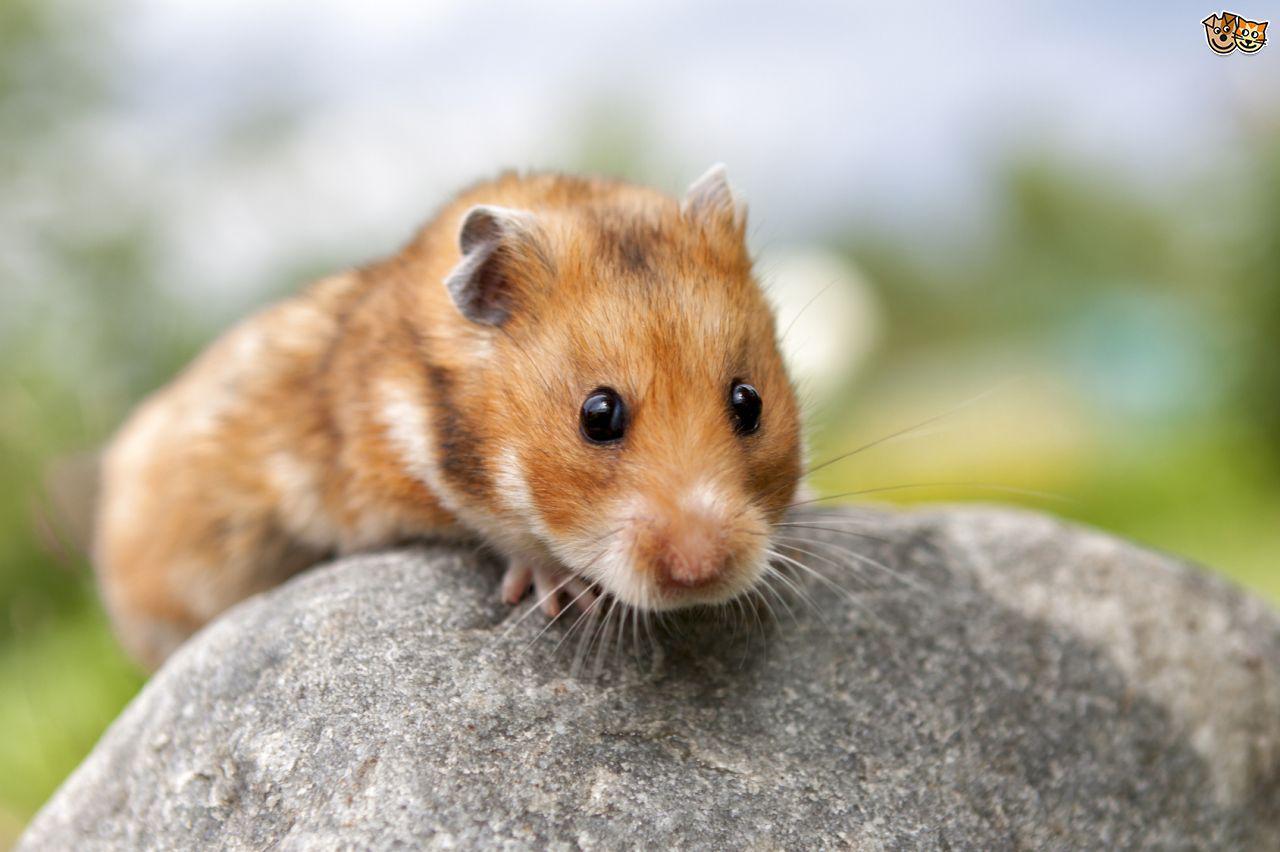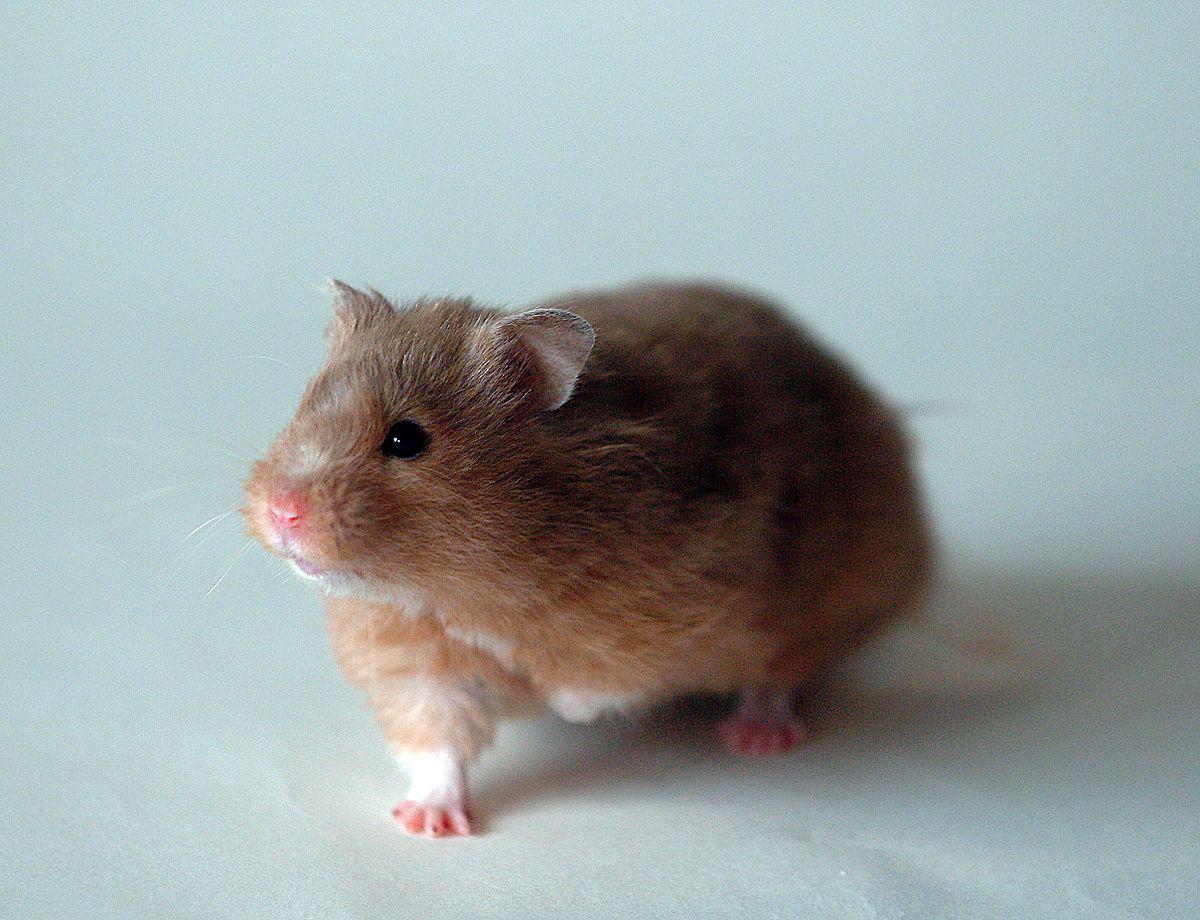The first image is the image on the left, the second image is the image on the right. Evaluate the accuracy of this statement regarding the images: "Each image contains exactly one pet rodent, and one of the animals poses bent forward with front paws off the ground and hind feet flat on the ground.". Is it true? Answer yes or no. No. The first image is the image on the left, the second image is the image on the right. Evaluate the accuracy of this statement regarding the images: "In at least one of the images, a small creature is interacting with a round object and the entire round object is visible.". Is it true? Answer yes or no. No. 